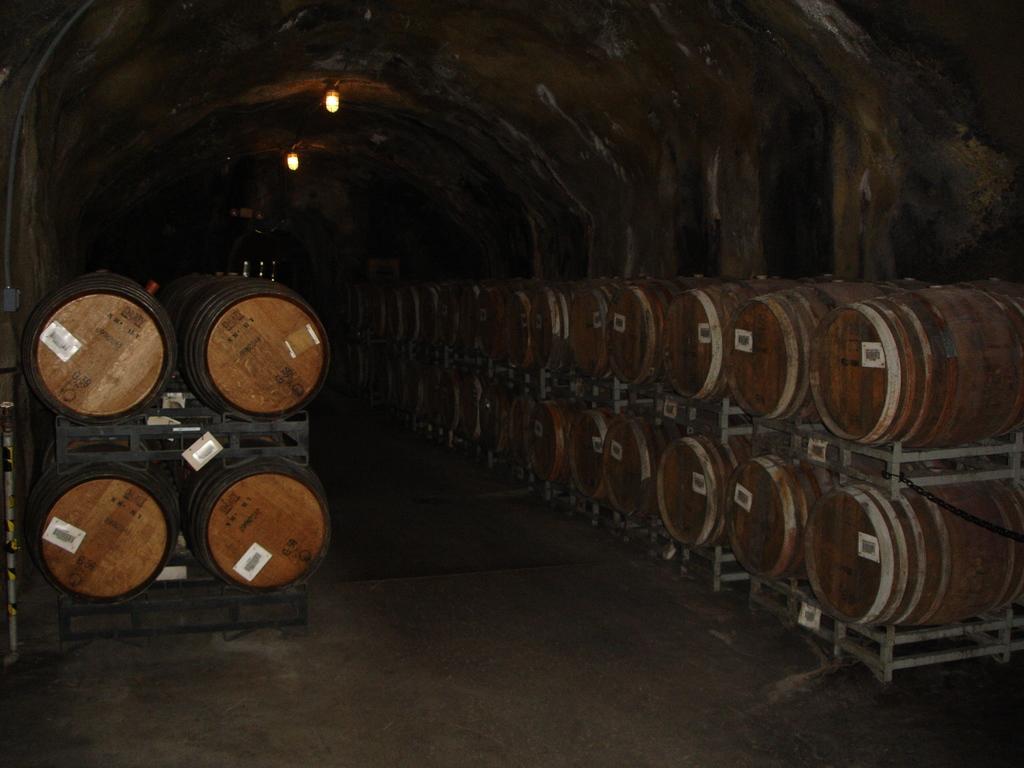How would you summarize this image in a sentence or two? There is a subway and a lot of goods are kept inside the subway,there are two lights fixed to the roof. 